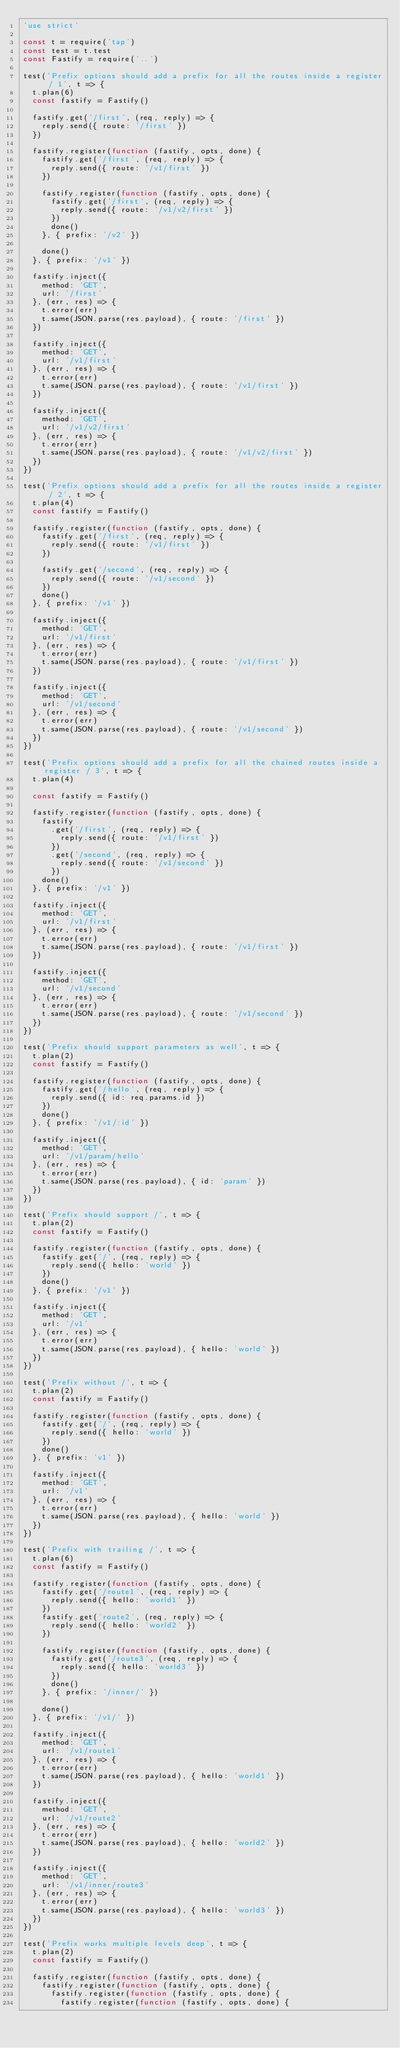Convert code to text. <code><loc_0><loc_0><loc_500><loc_500><_JavaScript_>'use strict'

const t = require('tap')
const test = t.test
const Fastify = require('..')

test('Prefix options should add a prefix for all the routes inside a register / 1', t => {
  t.plan(6)
  const fastify = Fastify()

  fastify.get('/first', (req, reply) => {
    reply.send({ route: '/first' })
  })

  fastify.register(function (fastify, opts, done) {
    fastify.get('/first', (req, reply) => {
      reply.send({ route: '/v1/first' })
    })

    fastify.register(function (fastify, opts, done) {
      fastify.get('/first', (req, reply) => {
        reply.send({ route: '/v1/v2/first' })
      })
      done()
    }, { prefix: '/v2' })

    done()
  }, { prefix: '/v1' })

  fastify.inject({
    method: 'GET',
    url: '/first'
  }, (err, res) => {
    t.error(err)
    t.same(JSON.parse(res.payload), { route: '/first' })
  })

  fastify.inject({
    method: 'GET',
    url: '/v1/first'
  }, (err, res) => {
    t.error(err)
    t.same(JSON.parse(res.payload), { route: '/v1/first' })
  })

  fastify.inject({
    method: 'GET',
    url: '/v1/v2/first'
  }, (err, res) => {
    t.error(err)
    t.same(JSON.parse(res.payload), { route: '/v1/v2/first' })
  })
})

test('Prefix options should add a prefix for all the routes inside a register / 2', t => {
  t.plan(4)
  const fastify = Fastify()

  fastify.register(function (fastify, opts, done) {
    fastify.get('/first', (req, reply) => {
      reply.send({ route: '/v1/first' })
    })

    fastify.get('/second', (req, reply) => {
      reply.send({ route: '/v1/second' })
    })
    done()
  }, { prefix: '/v1' })

  fastify.inject({
    method: 'GET',
    url: '/v1/first'
  }, (err, res) => {
    t.error(err)
    t.same(JSON.parse(res.payload), { route: '/v1/first' })
  })

  fastify.inject({
    method: 'GET',
    url: '/v1/second'
  }, (err, res) => {
    t.error(err)
    t.same(JSON.parse(res.payload), { route: '/v1/second' })
  })
})

test('Prefix options should add a prefix for all the chained routes inside a register / 3', t => {
  t.plan(4)

  const fastify = Fastify()

  fastify.register(function (fastify, opts, done) {
    fastify
      .get('/first', (req, reply) => {
        reply.send({ route: '/v1/first' })
      })
      .get('/second', (req, reply) => {
        reply.send({ route: '/v1/second' })
      })
    done()
  }, { prefix: '/v1' })

  fastify.inject({
    method: 'GET',
    url: '/v1/first'
  }, (err, res) => {
    t.error(err)
    t.same(JSON.parse(res.payload), { route: '/v1/first' })
  })

  fastify.inject({
    method: 'GET',
    url: '/v1/second'
  }, (err, res) => {
    t.error(err)
    t.same(JSON.parse(res.payload), { route: '/v1/second' })
  })
})

test('Prefix should support parameters as well', t => {
  t.plan(2)
  const fastify = Fastify()

  fastify.register(function (fastify, opts, done) {
    fastify.get('/hello', (req, reply) => {
      reply.send({ id: req.params.id })
    })
    done()
  }, { prefix: '/v1/:id' })

  fastify.inject({
    method: 'GET',
    url: '/v1/param/hello'
  }, (err, res) => {
    t.error(err)
    t.same(JSON.parse(res.payload), { id: 'param' })
  })
})

test('Prefix should support /', t => {
  t.plan(2)
  const fastify = Fastify()

  fastify.register(function (fastify, opts, done) {
    fastify.get('/', (req, reply) => {
      reply.send({ hello: 'world' })
    })
    done()
  }, { prefix: '/v1' })

  fastify.inject({
    method: 'GET',
    url: '/v1'
  }, (err, res) => {
    t.error(err)
    t.same(JSON.parse(res.payload), { hello: 'world' })
  })
})

test('Prefix without /', t => {
  t.plan(2)
  const fastify = Fastify()

  fastify.register(function (fastify, opts, done) {
    fastify.get('/', (req, reply) => {
      reply.send({ hello: 'world' })
    })
    done()
  }, { prefix: 'v1' })

  fastify.inject({
    method: 'GET',
    url: '/v1'
  }, (err, res) => {
    t.error(err)
    t.same(JSON.parse(res.payload), { hello: 'world' })
  })
})

test('Prefix with trailing /', t => {
  t.plan(6)
  const fastify = Fastify()

  fastify.register(function (fastify, opts, done) {
    fastify.get('/route1', (req, reply) => {
      reply.send({ hello: 'world1' })
    })
    fastify.get('route2', (req, reply) => {
      reply.send({ hello: 'world2' })
    })

    fastify.register(function (fastify, opts, done) {
      fastify.get('/route3', (req, reply) => {
        reply.send({ hello: 'world3' })
      })
      done()
    }, { prefix: '/inner/' })

    done()
  }, { prefix: '/v1/' })

  fastify.inject({
    method: 'GET',
    url: '/v1/route1'
  }, (err, res) => {
    t.error(err)
    t.same(JSON.parse(res.payload), { hello: 'world1' })
  })

  fastify.inject({
    method: 'GET',
    url: '/v1/route2'
  }, (err, res) => {
    t.error(err)
    t.same(JSON.parse(res.payload), { hello: 'world2' })
  })

  fastify.inject({
    method: 'GET',
    url: '/v1/inner/route3'
  }, (err, res) => {
    t.error(err)
    t.same(JSON.parse(res.payload), { hello: 'world3' })
  })
})

test('Prefix works multiple levels deep', t => {
  t.plan(2)
  const fastify = Fastify()

  fastify.register(function (fastify, opts, done) {
    fastify.register(function (fastify, opts, done) {
      fastify.register(function (fastify, opts, done) {
        fastify.register(function (fastify, opts, done) {</code> 